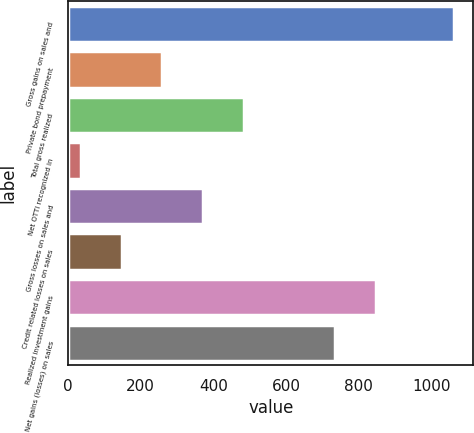<chart> <loc_0><loc_0><loc_500><loc_500><bar_chart><fcel>Gross gains on sales and<fcel>Private bond prepayment<fcel>Total gross realized<fcel>Net OTTI recognized in<fcel>Gross losses on sales and<fcel>Credit related losses on sales<fcel>Realized investment gains<fcel>Net gains (losses) on sales<nl><fcel>1063<fcel>259.6<fcel>483.2<fcel>36<fcel>371.4<fcel>147.8<fcel>847.8<fcel>736<nl></chart> 